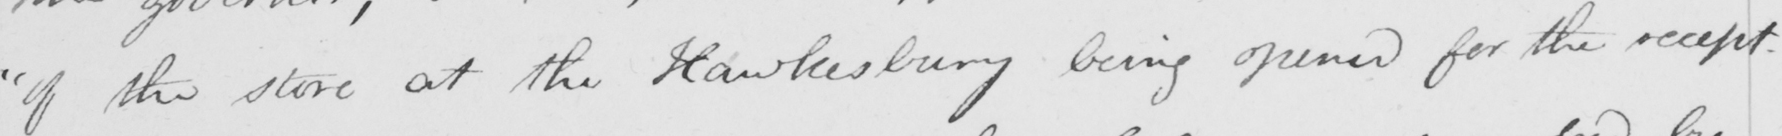What is written in this line of handwriting? " if the store at the Hawkesbury being opened for the recept- 